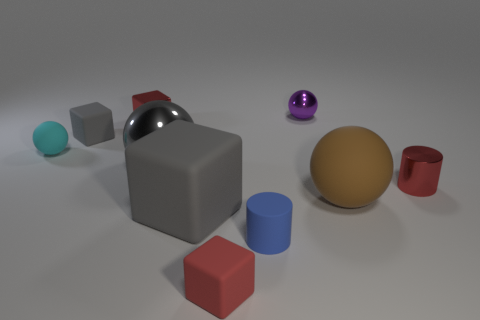Subtract all small shiny cubes. How many cubes are left? 3 Subtract 3 blocks. How many blocks are left? 1 Subtract all spheres. How many objects are left? 6 Subtract all brown balls. How many balls are left? 3 Subtract all brown cubes. Subtract all purple balls. How many cubes are left? 4 Subtract all cyan balls. How many yellow blocks are left? 0 Subtract all gray metallic balls. Subtract all large gray metallic objects. How many objects are left? 8 Add 7 metallic cylinders. How many metallic cylinders are left? 8 Add 3 cyan metal objects. How many cyan metal objects exist? 3 Subtract 2 red cubes. How many objects are left? 8 